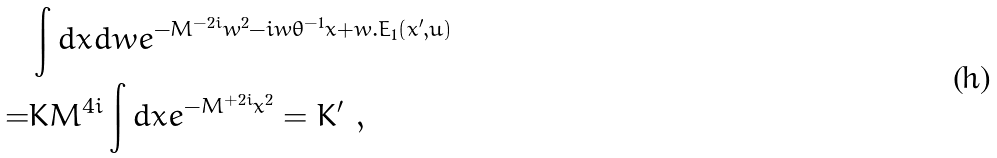<formula> <loc_0><loc_0><loc_500><loc_500>& \int d x d w e ^ { - M ^ { - 2 i } w ^ { 2 } - i w \theta ^ { - 1 } x + w . E _ { 1 } ( x ^ { \prime } , u ) } \\ = & K M ^ { 4 i } \int d x e ^ { - M ^ { + 2 i } x ^ { 2 } } = K ^ { \prime } \ ,</formula> 